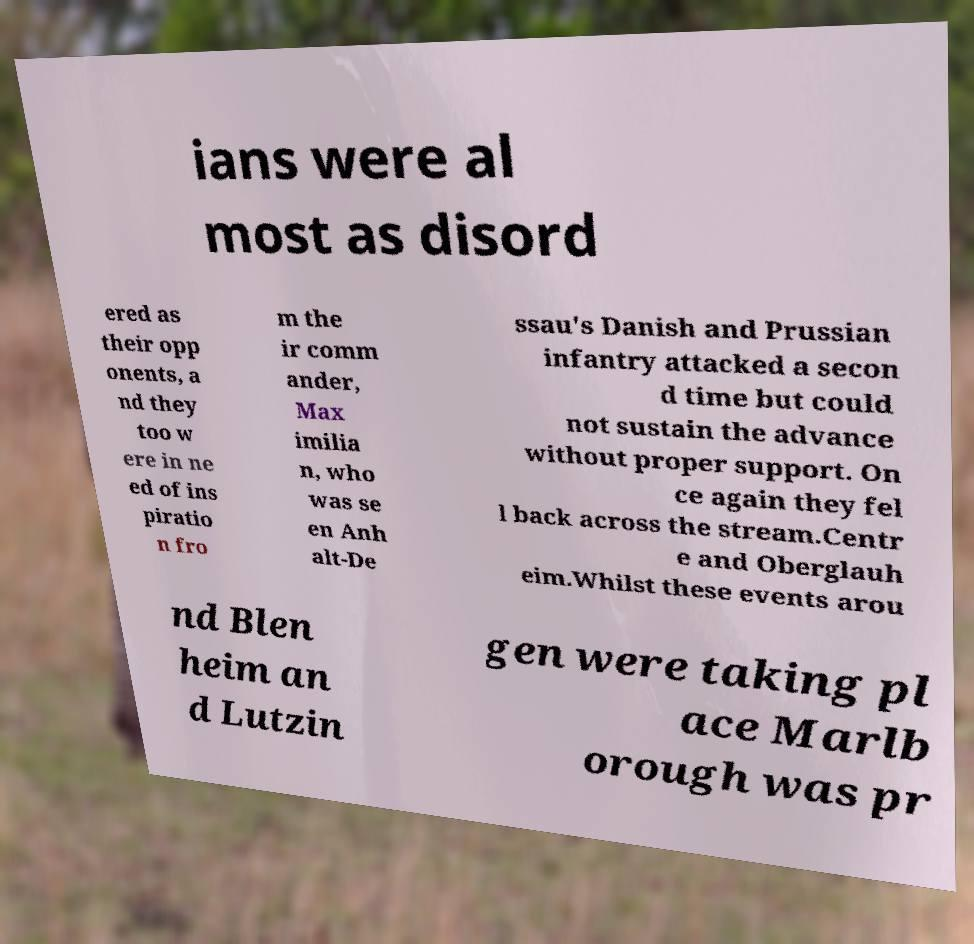I need the written content from this picture converted into text. Can you do that? ians were al most as disord ered as their opp onents, a nd they too w ere in ne ed of ins piratio n fro m the ir comm ander, Max imilia n, who was se en Anh alt-De ssau's Danish and Prussian infantry attacked a secon d time but could not sustain the advance without proper support. On ce again they fel l back across the stream.Centr e and Oberglauh eim.Whilst these events arou nd Blen heim an d Lutzin gen were taking pl ace Marlb orough was pr 